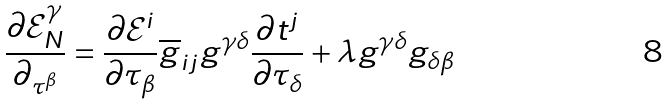Convert formula to latex. <formula><loc_0><loc_0><loc_500><loc_500>\frac { \partial \mathcal { E } _ { N } ^ { \gamma } } { \partial _ { \tau ^ { \beta } } } = \frac { \partial \mathcal { E } ^ { i } } { \partial \tau _ { \beta } } \overline { g } _ { i j } g ^ { \gamma \delta } \frac { \partial t ^ { j } } { \partial \tau _ { \delta } } + \lambda g ^ { \gamma \delta } g _ { \delta \beta }</formula> 